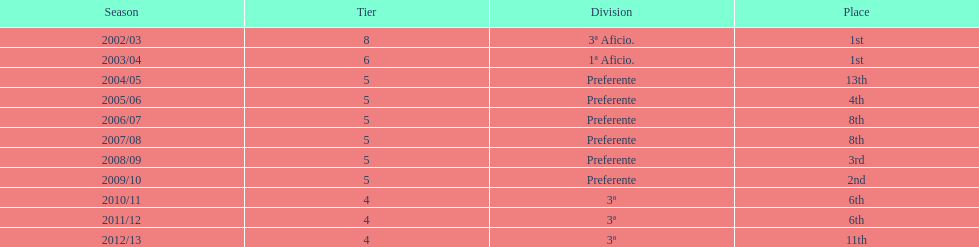How long did the team stay in first place? 2 years. 